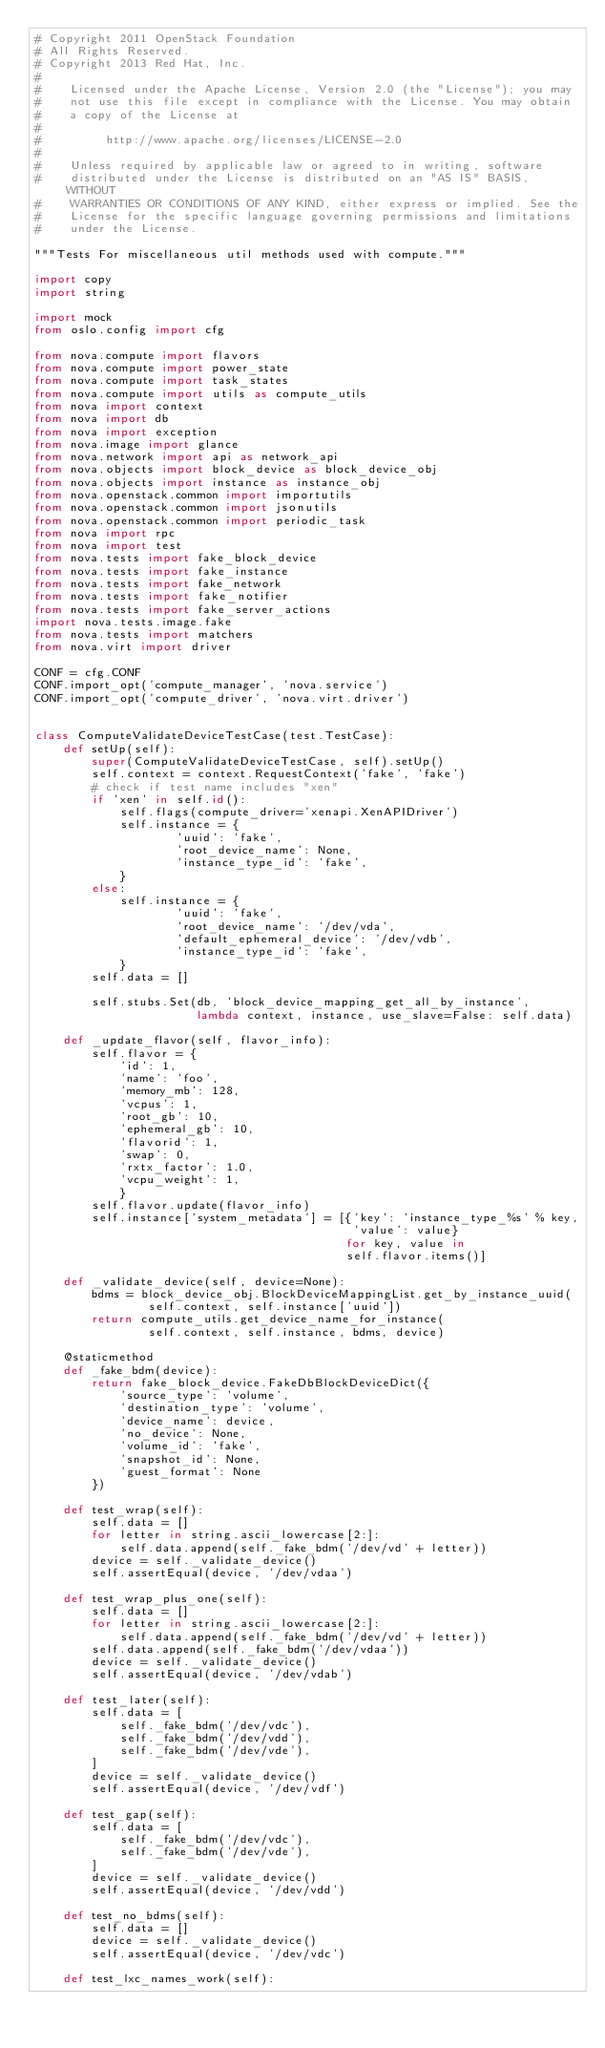Convert code to text. <code><loc_0><loc_0><loc_500><loc_500><_Python_># Copyright 2011 OpenStack Foundation
# All Rights Reserved.
# Copyright 2013 Red Hat, Inc.
#
#    Licensed under the Apache License, Version 2.0 (the "License"); you may
#    not use this file except in compliance with the License. You may obtain
#    a copy of the License at
#
#         http://www.apache.org/licenses/LICENSE-2.0
#
#    Unless required by applicable law or agreed to in writing, software
#    distributed under the License is distributed on an "AS IS" BASIS, WITHOUT
#    WARRANTIES OR CONDITIONS OF ANY KIND, either express or implied. See the
#    License for the specific language governing permissions and limitations
#    under the License.

"""Tests For miscellaneous util methods used with compute."""

import copy
import string

import mock
from oslo.config import cfg

from nova.compute import flavors
from nova.compute import power_state
from nova.compute import task_states
from nova.compute import utils as compute_utils
from nova import context
from nova import db
from nova import exception
from nova.image import glance
from nova.network import api as network_api
from nova.objects import block_device as block_device_obj
from nova.objects import instance as instance_obj
from nova.openstack.common import importutils
from nova.openstack.common import jsonutils
from nova.openstack.common import periodic_task
from nova import rpc
from nova import test
from nova.tests import fake_block_device
from nova.tests import fake_instance
from nova.tests import fake_network
from nova.tests import fake_notifier
from nova.tests import fake_server_actions
import nova.tests.image.fake
from nova.tests import matchers
from nova.virt import driver

CONF = cfg.CONF
CONF.import_opt('compute_manager', 'nova.service')
CONF.import_opt('compute_driver', 'nova.virt.driver')


class ComputeValidateDeviceTestCase(test.TestCase):
    def setUp(self):
        super(ComputeValidateDeviceTestCase, self).setUp()
        self.context = context.RequestContext('fake', 'fake')
        # check if test name includes "xen"
        if 'xen' in self.id():
            self.flags(compute_driver='xenapi.XenAPIDriver')
            self.instance = {
                    'uuid': 'fake',
                    'root_device_name': None,
                    'instance_type_id': 'fake',
            }
        else:
            self.instance = {
                    'uuid': 'fake',
                    'root_device_name': '/dev/vda',
                    'default_ephemeral_device': '/dev/vdb',
                    'instance_type_id': 'fake',
            }
        self.data = []

        self.stubs.Set(db, 'block_device_mapping_get_all_by_instance',
                       lambda context, instance, use_slave=False: self.data)

    def _update_flavor(self, flavor_info):
        self.flavor = {
            'id': 1,
            'name': 'foo',
            'memory_mb': 128,
            'vcpus': 1,
            'root_gb': 10,
            'ephemeral_gb': 10,
            'flavorid': 1,
            'swap': 0,
            'rxtx_factor': 1.0,
            'vcpu_weight': 1,
            }
        self.flavor.update(flavor_info)
        self.instance['system_metadata'] = [{'key': 'instance_type_%s' % key,
                                             'value': value}
                                            for key, value in
                                            self.flavor.items()]

    def _validate_device(self, device=None):
        bdms = block_device_obj.BlockDeviceMappingList.get_by_instance_uuid(
                self.context, self.instance['uuid'])
        return compute_utils.get_device_name_for_instance(
                self.context, self.instance, bdms, device)

    @staticmethod
    def _fake_bdm(device):
        return fake_block_device.FakeDbBlockDeviceDict({
            'source_type': 'volume',
            'destination_type': 'volume',
            'device_name': device,
            'no_device': None,
            'volume_id': 'fake',
            'snapshot_id': None,
            'guest_format': None
        })

    def test_wrap(self):
        self.data = []
        for letter in string.ascii_lowercase[2:]:
            self.data.append(self._fake_bdm('/dev/vd' + letter))
        device = self._validate_device()
        self.assertEqual(device, '/dev/vdaa')

    def test_wrap_plus_one(self):
        self.data = []
        for letter in string.ascii_lowercase[2:]:
            self.data.append(self._fake_bdm('/dev/vd' + letter))
        self.data.append(self._fake_bdm('/dev/vdaa'))
        device = self._validate_device()
        self.assertEqual(device, '/dev/vdab')

    def test_later(self):
        self.data = [
            self._fake_bdm('/dev/vdc'),
            self._fake_bdm('/dev/vdd'),
            self._fake_bdm('/dev/vde'),
        ]
        device = self._validate_device()
        self.assertEqual(device, '/dev/vdf')

    def test_gap(self):
        self.data = [
            self._fake_bdm('/dev/vdc'),
            self._fake_bdm('/dev/vde'),
        ]
        device = self._validate_device()
        self.assertEqual(device, '/dev/vdd')

    def test_no_bdms(self):
        self.data = []
        device = self._validate_device()
        self.assertEqual(device, '/dev/vdc')

    def test_lxc_names_work(self):</code> 